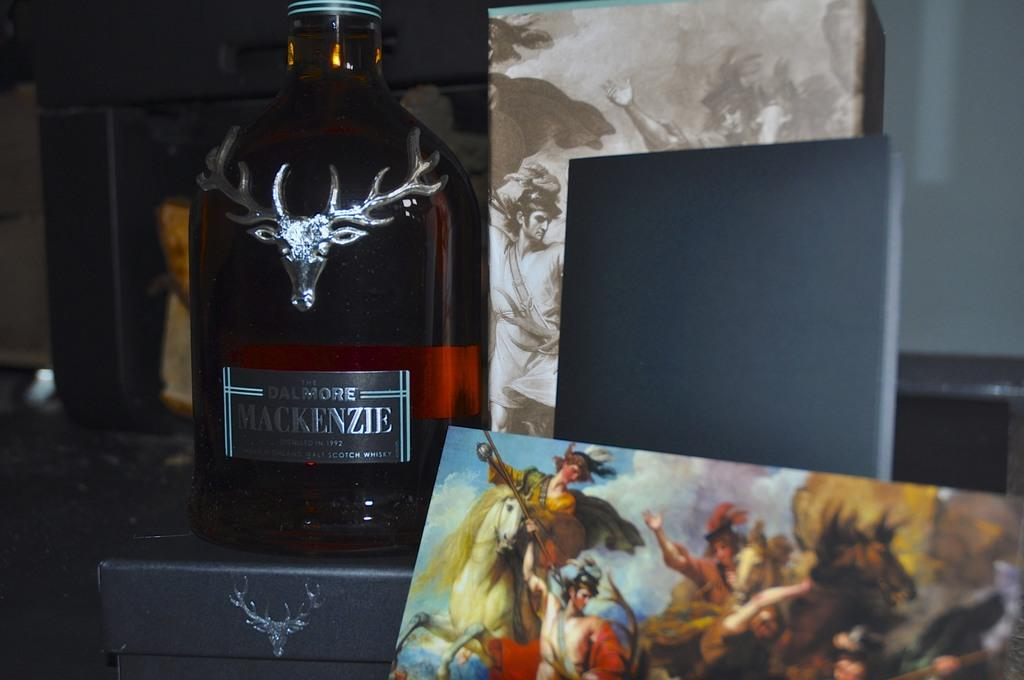Provide a one-sentence caption for the provided image. A bottle of Dalmore Mackenzie Scotch from 1992 with a silver stag head on the bottle. 